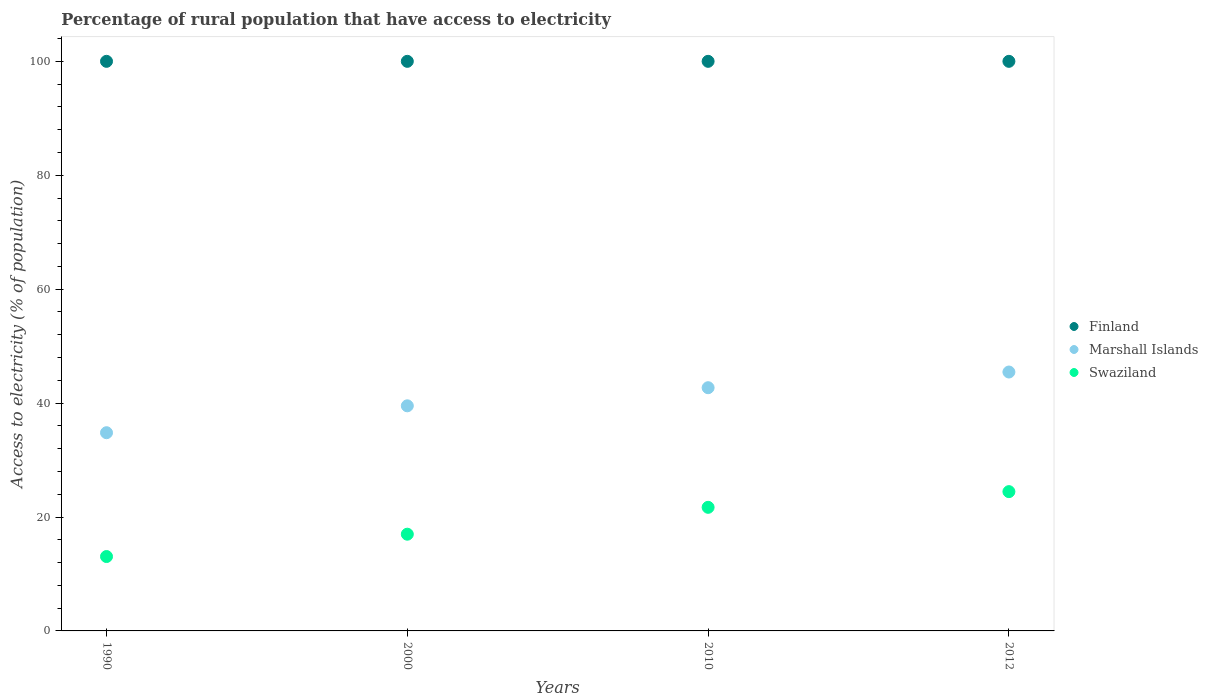What is the percentage of rural population that have access to electricity in Finland in 2010?
Your response must be concise. 100. Across all years, what is the maximum percentage of rural population that have access to electricity in Marshall Islands?
Keep it short and to the point. 45.45. Across all years, what is the minimum percentage of rural population that have access to electricity in Marshall Islands?
Your answer should be compact. 34.8. In which year was the percentage of rural population that have access to electricity in Swaziland maximum?
Your answer should be very brief. 2012. In which year was the percentage of rural population that have access to electricity in Swaziland minimum?
Make the answer very short. 1990. What is the total percentage of rural population that have access to electricity in Finland in the graph?
Keep it short and to the point. 400. What is the difference between the percentage of rural population that have access to electricity in Marshall Islands in 2000 and that in 2012?
Offer a very short reply. -5.93. What is the difference between the percentage of rural population that have access to electricity in Marshall Islands in 1990 and the percentage of rural population that have access to electricity in Swaziland in 2012?
Make the answer very short. 10.34. What is the average percentage of rural population that have access to electricity in Marshall Islands per year?
Ensure brevity in your answer.  40.62. In the year 2000, what is the difference between the percentage of rural population that have access to electricity in Marshall Islands and percentage of rural population that have access to electricity in Finland?
Offer a very short reply. -60.48. In how many years, is the percentage of rural population that have access to electricity in Marshall Islands greater than 92 %?
Offer a very short reply. 0. What is the ratio of the percentage of rural population that have access to electricity in Marshall Islands in 1990 to that in 2000?
Ensure brevity in your answer.  0.88. Is the percentage of rural population that have access to electricity in Finland in 1990 less than that in 2010?
Offer a very short reply. No. Is the difference between the percentage of rural population that have access to electricity in Marshall Islands in 1990 and 2012 greater than the difference between the percentage of rural population that have access to electricity in Finland in 1990 and 2012?
Give a very brief answer. No. What is the difference between the highest and the lowest percentage of rural population that have access to electricity in Swaziland?
Provide a short and direct response. 11.39. Is the sum of the percentage of rural population that have access to electricity in Finland in 2000 and 2012 greater than the maximum percentage of rural population that have access to electricity in Swaziland across all years?
Provide a succinct answer. Yes. Is it the case that in every year, the sum of the percentage of rural population that have access to electricity in Marshall Islands and percentage of rural population that have access to electricity in Finland  is greater than the percentage of rural population that have access to electricity in Swaziland?
Keep it short and to the point. Yes. Does the percentage of rural population that have access to electricity in Marshall Islands monotonically increase over the years?
Provide a succinct answer. Yes. How many dotlines are there?
Make the answer very short. 3. Are the values on the major ticks of Y-axis written in scientific E-notation?
Offer a very short reply. No. Does the graph contain any zero values?
Your answer should be very brief. No. How many legend labels are there?
Make the answer very short. 3. What is the title of the graph?
Your answer should be very brief. Percentage of rural population that have access to electricity. What is the label or title of the X-axis?
Offer a terse response. Years. What is the label or title of the Y-axis?
Keep it short and to the point. Access to electricity (% of population). What is the Access to electricity (% of population) of Finland in 1990?
Your answer should be very brief. 100. What is the Access to electricity (% of population) of Marshall Islands in 1990?
Your answer should be compact. 34.8. What is the Access to electricity (% of population) of Swaziland in 1990?
Provide a succinct answer. 13.06. What is the Access to electricity (% of population) in Finland in 2000?
Provide a short and direct response. 100. What is the Access to electricity (% of population) in Marshall Islands in 2000?
Offer a very short reply. 39.52. What is the Access to electricity (% of population) in Swaziland in 2000?
Your response must be concise. 16.98. What is the Access to electricity (% of population) of Finland in 2010?
Offer a terse response. 100. What is the Access to electricity (% of population) of Marshall Islands in 2010?
Provide a short and direct response. 42.7. What is the Access to electricity (% of population) in Swaziland in 2010?
Your answer should be compact. 21.7. What is the Access to electricity (% of population) in Marshall Islands in 2012?
Your response must be concise. 45.45. What is the Access to electricity (% of population) in Swaziland in 2012?
Provide a short and direct response. 24.45. Across all years, what is the maximum Access to electricity (% of population) of Marshall Islands?
Provide a succinct answer. 45.45. Across all years, what is the maximum Access to electricity (% of population) of Swaziland?
Give a very brief answer. 24.45. Across all years, what is the minimum Access to electricity (% of population) in Marshall Islands?
Provide a succinct answer. 34.8. Across all years, what is the minimum Access to electricity (% of population) of Swaziland?
Your response must be concise. 13.06. What is the total Access to electricity (% of population) in Marshall Islands in the graph?
Provide a succinct answer. 162.47. What is the total Access to electricity (% of population) of Swaziland in the graph?
Provide a succinct answer. 76.2. What is the difference between the Access to electricity (% of population) in Marshall Islands in 1990 and that in 2000?
Your answer should be very brief. -4.72. What is the difference between the Access to electricity (% of population) in Swaziland in 1990 and that in 2000?
Your answer should be very brief. -3.92. What is the difference between the Access to electricity (% of population) of Finland in 1990 and that in 2010?
Your answer should be very brief. 0. What is the difference between the Access to electricity (% of population) in Marshall Islands in 1990 and that in 2010?
Give a very brief answer. -7.9. What is the difference between the Access to electricity (% of population) of Swaziland in 1990 and that in 2010?
Your answer should be very brief. -8.64. What is the difference between the Access to electricity (% of population) in Finland in 1990 and that in 2012?
Offer a very short reply. 0. What is the difference between the Access to electricity (% of population) of Marshall Islands in 1990 and that in 2012?
Make the answer very short. -10.66. What is the difference between the Access to electricity (% of population) in Swaziland in 1990 and that in 2012?
Your response must be concise. -11.39. What is the difference between the Access to electricity (% of population) of Marshall Islands in 2000 and that in 2010?
Provide a succinct answer. -3.18. What is the difference between the Access to electricity (% of population) of Swaziland in 2000 and that in 2010?
Your response must be concise. -4.72. What is the difference between the Access to electricity (% of population) in Marshall Islands in 2000 and that in 2012?
Make the answer very short. -5.93. What is the difference between the Access to electricity (% of population) of Swaziland in 2000 and that in 2012?
Your response must be concise. -7.47. What is the difference between the Access to electricity (% of population) of Marshall Islands in 2010 and that in 2012?
Your response must be concise. -2.75. What is the difference between the Access to electricity (% of population) in Swaziland in 2010 and that in 2012?
Your answer should be very brief. -2.75. What is the difference between the Access to electricity (% of population) of Finland in 1990 and the Access to electricity (% of population) of Marshall Islands in 2000?
Give a very brief answer. 60.48. What is the difference between the Access to electricity (% of population) of Finland in 1990 and the Access to electricity (% of population) of Swaziland in 2000?
Make the answer very short. 83.02. What is the difference between the Access to electricity (% of population) of Marshall Islands in 1990 and the Access to electricity (% of population) of Swaziland in 2000?
Ensure brevity in your answer.  17.82. What is the difference between the Access to electricity (% of population) in Finland in 1990 and the Access to electricity (% of population) in Marshall Islands in 2010?
Make the answer very short. 57.3. What is the difference between the Access to electricity (% of population) of Finland in 1990 and the Access to electricity (% of population) of Swaziland in 2010?
Provide a succinct answer. 78.3. What is the difference between the Access to electricity (% of population) in Marshall Islands in 1990 and the Access to electricity (% of population) in Swaziland in 2010?
Give a very brief answer. 13.1. What is the difference between the Access to electricity (% of population) of Finland in 1990 and the Access to electricity (% of population) of Marshall Islands in 2012?
Give a very brief answer. 54.55. What is the difference between the Access to electricity (% of population) in Finland in 1990 and the Access to electricity (% of population) in Swaziland in 2012?
Provide a succinct answer. 75.55. What is the difference between the Access to electricity (% of population) of Marshall Islands in 1990 and the Access to electricity (% of population) of Swaziland in 2012?
Provide a succinct answer. 10.34. What is the difference between the Access to electricity (% of population) of Finland in 2000 and the Access to electricity (% of population) of Marshall Islands in 2010?
Provide a short and direct response. 57.3. What is the difference between the Access to electricity (% of population) of Finland in 2000 and the Access to electricity (% of population) of Swaziland in 2010?
Offer a very short reply. 78.3. What is the difference between the Access to electricity (% of population) of Marshall Islands in 2000 and the Access to electricity (% of population) of Swaziland in 2010?
Your response must be concise. 17.82. What is the difference between the Access to electricity (% of population) in Finland in 2000 and the Access to electricity (% of population) in Marshall Islands in 2012?
Keep it short and to the point. 54.55. What is the difference between the Access to electricity (% of population) in Finland in 2000 and the Access to electricity (% of population) in Swaziland in 2012?
Your answer should be very brief. 75.55. What is the difference between the Access to electricity (% of population) in Marshall Islands in 2000 and the Access to electricity (% of population) in Swaziland in 2012?
Your answer should be very brief. 15.07. What is the difference between the Access to electricity (% of population) of Finland in 2010 and the Access to electricity (% of population) of Marshall Islands in 2012?
Provide a succinct answer. 54.55. What is the difference between the Access to electricity (% of population) in Finland in 2010 and the Access to electricity (% of population) in Swaziland in 2012?
Your answer should be compact. 75.55. What is the difference between the Access to electricity (% of population) of Marshall Islands in 2010 and the Access to electricity (% of population) of Swaziland in 2012?
Ensure brevity in your answer.  18.25. What is the average Access to electricity (% of population) in Marshall Islands per year?
Ensure brevity in your answer.  40.62. What is the average Access to electricity (% of population) in Swaziland per year?
Your answer should be compact. 19.05. In the year 1990, what is the difference between the Access to electricity (% of population) in Finland and Access to electricity (% of population) in Marshall Islands?
Keep it short and to the point. 65.2. In the year 1990, what is the difference between the Access to electricity (% of population) in Finland and Access to electricity (% of population) in Swaziland?
Make the answer very short. 86.94. In the year 1990, what is the difference between the Access to electricity (% of population) of Marshall Islands and Access to electricity (% of population) of Swaziland?
Provide a succinct answer. 21.74. In the year 2000, what is the difference between the Access to electricity (% of population) of Finland and Access to electricity (% of population) of Marshall Islands?
Make the answer very short. 60.48. In the year 2000, what is the difference between the Access to electricity (% of population) of Finland and Access to electricity (% of population) of Swaziland?
Offer a terse response. 83.02. In the year 2000, what is the difference between the Access to electricity (% of population) of Marshall Islands and Access to electricity (% of population) of Swaziland?
Provide a succinct answer. 22.54. In the year 2010, what is the difference between the Access to electricity (% of population) in Finland and Access to electricity (% of population) in Marshall Islands?
Ensure brevity in your answer.  57.3. In the year 2010, what is the difference between the Access to electricity (% of population) in Finland and Access to electricity (% of population) in Swaziland?
Your response must be concise. 78.3. In the year 2012, what is the difference between the Access to electricity (% of population) of Finland and Access to electricity (% of population) of Marshall Islands?
Make the answer very short. 54.55. In the year 2012, what is the difference between the Access to electricity (% of population) in Finland and Access to electricity (% of population) in Swaziland?
Your answer should be very brief. 75.55. What is the ratio of the Access to electricity (% of population) in Finland in 1990 to that in 2000?
Your answer should be very brief. 1. What is the ratio of the Access to electricity (% of population) in Marshall Islands in 1990 to that in 2000?
Your response must be concise. 0.88. What is the ratio of the Access to electricity (% of population) in Swaziland in 1990 to that in 2000?
Provide a short and direct response. 0.77. What is the ratio of the Access to electricity (% of population) in Finland in 1990 to that in 2010?
Ensure brevity in your answer.  1. What is the ratio of the Access to electricity (% of population) in Marshall Islands in 1990 to that in 2010?
Ensure brevity in your answer.  0.81. What is the ratio of the Access to electricity (% of population) of Swaziland in 1990 to that in 2010?
Ensure brevity in your answer.  0.6. What is the ratio of the Access to electricity (% of population) in Marshall Islands in 1990 to that in 2012?
Your answer should be very brief. 0.77. What is the ratio of the Access to electricity (% of population) in Swaziland in 1990 to that in 2012?
Your answer should be very brief. 0.53. What is the ratio of the Access to electricity (% of population) in Finland in 2000 to that in 2010?
Give a very brief answer. 1. What is the ratio of the Access to electricity (% of population) in Marshall Islands in 2000 to that in 2010?
Your response must be concise. 0.93. What is the ratio of the Access to electricity (% of population) in Swaziland in 2000 to that in 2010?
Ensure brevity in your answer.  0.78. What is the ratio of the Access to electricity (% of population) of Marshall Islands in 2000 to that in 2012?
Provide a short and direct response. 0.87. What is the ratio of the Access to electricity (% of population) of Swaziland in 2000 to that in 2012?
Ensure brevity in your answer.  0.69. What is the ratio of the Access to electricity (% of population) in Marshall Islands in 2010 to that in 2012?
Offer a terse response. 0.94. What is the ratio of the Access to electricity (% of population) of Swaziland in 2010 to that in 2012?
Give a very brief answer. 0.89. What is the difference between the highest and the second highest Access to electricity (% of population) of Marshall Islands?
Ensure brevity in your answer.  2.75. What is the difference between the highest and the second highest Access to electricity (% of population) in Swaziland?
Give a very brief answer. 2.75. What is the difference between the highest and the lowest Access to electricity (% of population) of Finland?
Provide a succinct answer. 0. What is the difference between the highest and the lowest Access to electricity (% of population) in Marshall Islands?
Provide a succinct answer. 10.66. What is the difference between the highest and the lowest Access to electricity (% of population) in Swaziland?
Keep it short and to the point. 11.39. 